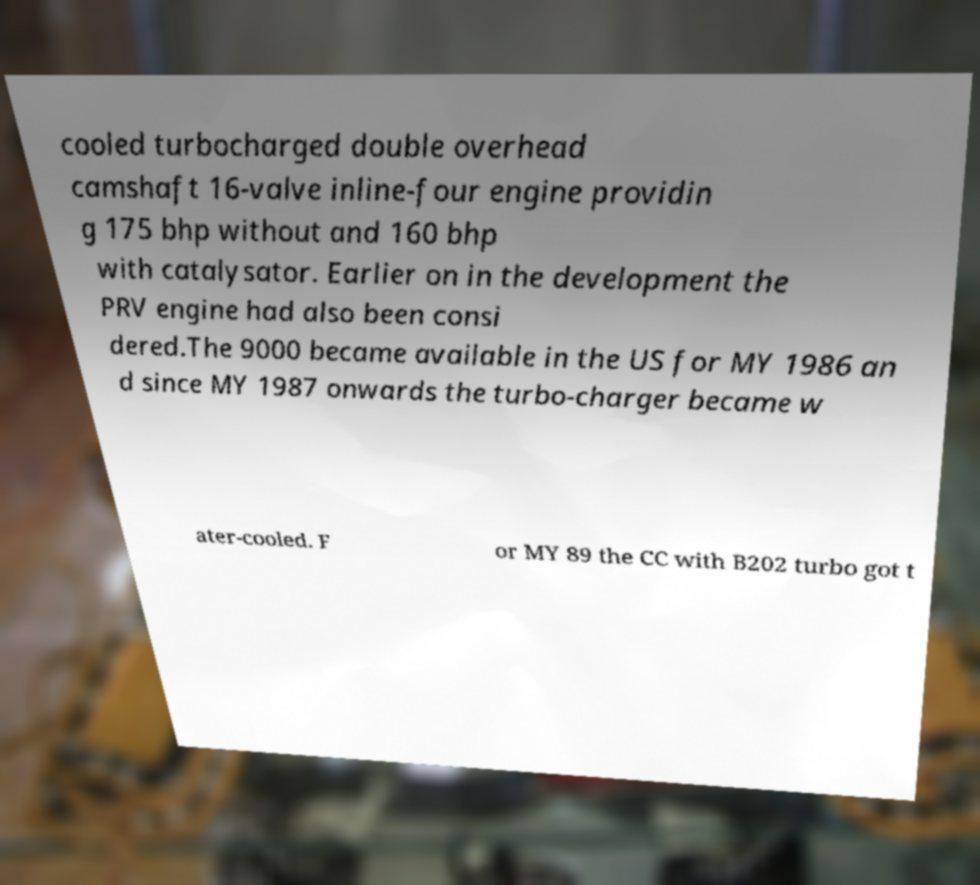Please read and relay the text visible in this image. What does it say? cooled turbocharged double overhead camshaft 16-valve inline-four engine providin g 175 bhp without and 160 bhp with catalysator. Earlier on in the development the PRV engine had also been consi dered.The 9000 became available in the US for MY 1986 an d since MY 1987 onwards the turbo-charger became w ater-cooled. F or MY 89 the CC with B202 turbo got t 